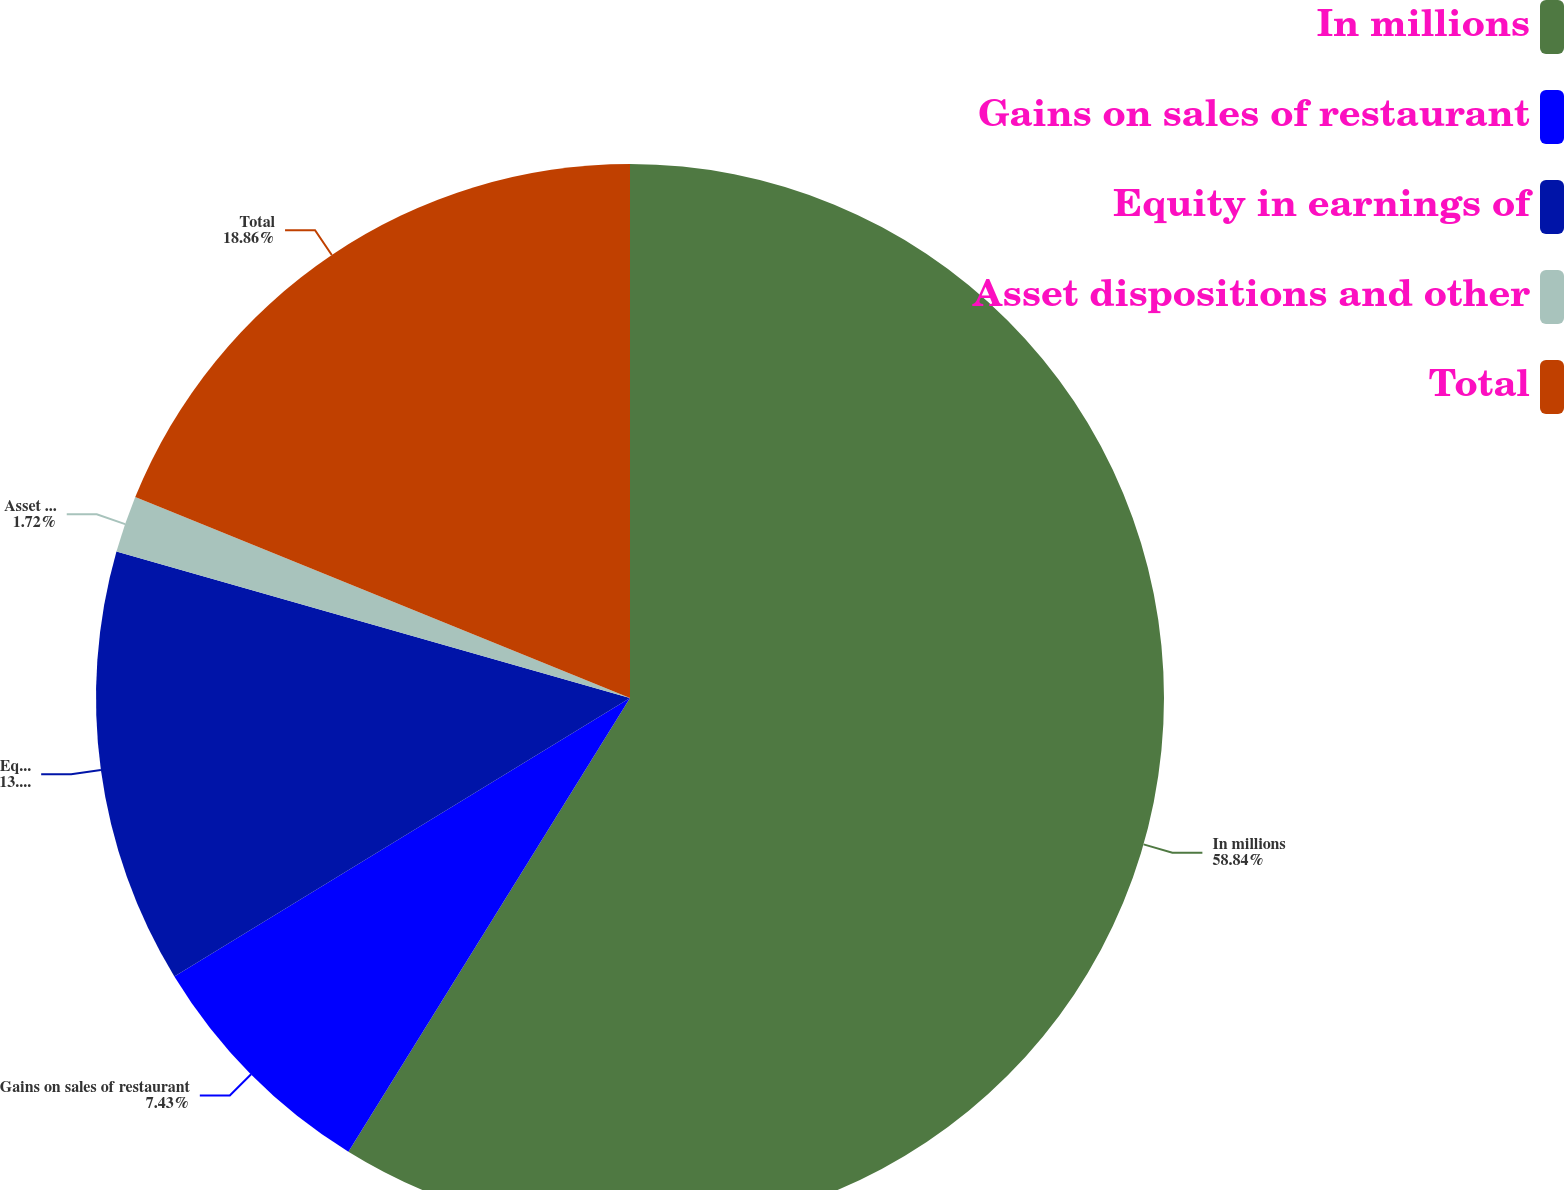Convert chart to OTSL. <chart><loc_0><loc_0><loc_500><loc_500><pie_chart><fcel>In millions<fcel>Gains on sales of restaurant<fcel>Equity in earnings of<fcel>Asset dispositions and other<fcel>Total<nl><fcel>58.84%<fcel>7.43%<fcel>13.15%<fcel>1.72%<fcel>18.86%<nl></chart> 